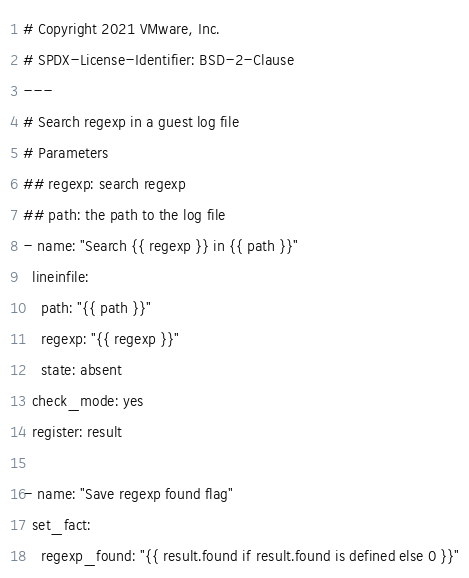<code> <loc_0><loc_0><loc_500><loc_500><_YAML_># Copyright 2021 VMware, Inc.
# SPDX-License-Identifier: BSD-2-Clause
---
# Search regexp in a guest log file
# Parameters
## regexp: search regexp
## path: the path to the log file
- name: "Search {{ regexp }} in {{ path }}"
  lineinfile:
    path: "{{ path }}"
    regexp: "{{ regexp }}"
    state: absent
  check_mode: yes
  register: result

- name: "Save regexp found flag"
  set_fact:
    regexp_found: "{{ result.found if result.found is defined else 0 }}"
</code> 